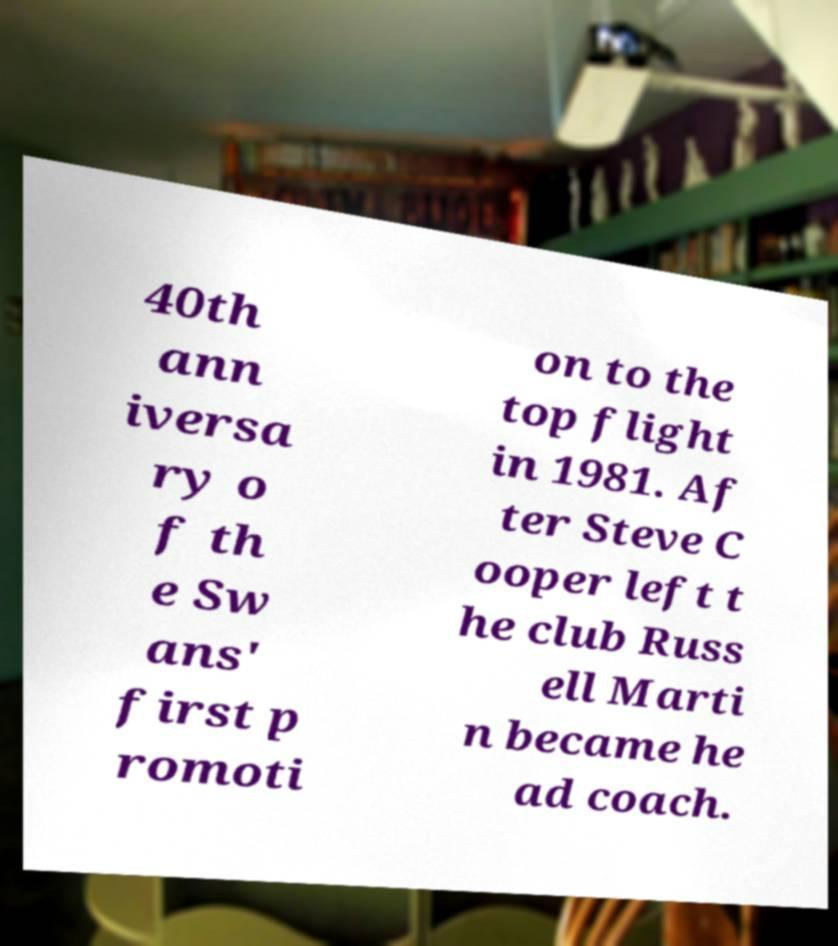Please read and relay the text visible in this image. What does it say? 40th ann iversa ry o f th e Sw ans' first p romoti on to the top flight in 1981. Af ter Steve C ooper left t he club Russ ell Marti n became he ad coach. 